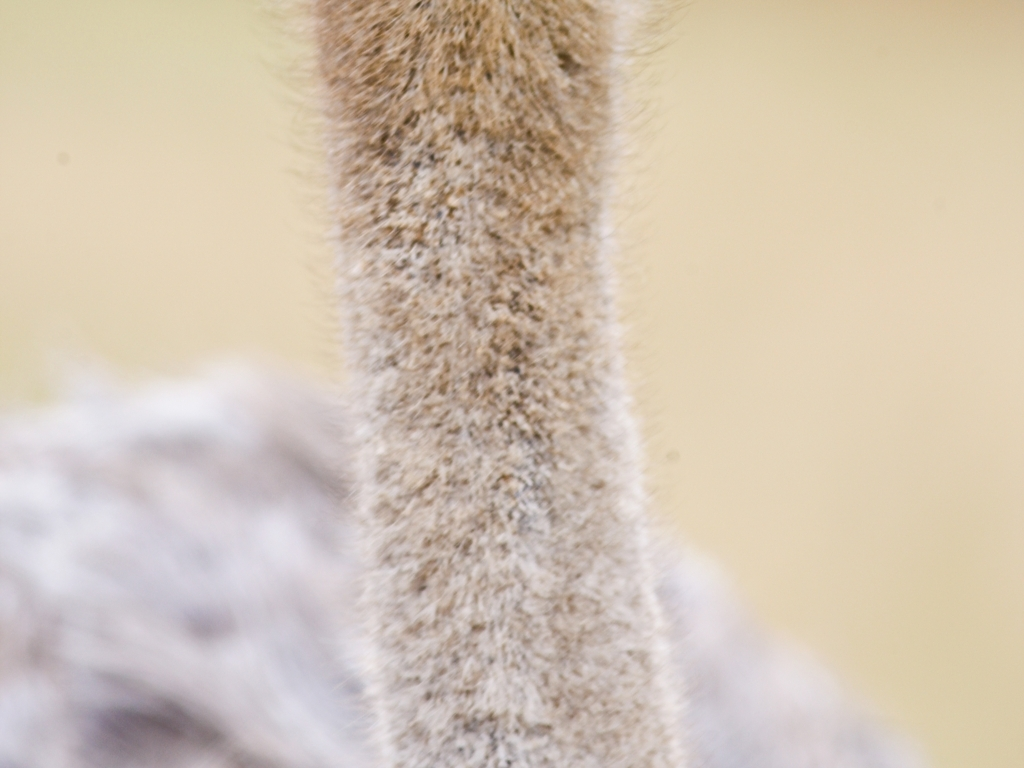What kind of habitat is suitable for the animal in the image? Given the limited view of the animal, it's difficult to determine the exact species, but based on the visible coat texture, it could be an animal that frequents arid or savanna habitats, where such fur would provide good camouflage. 